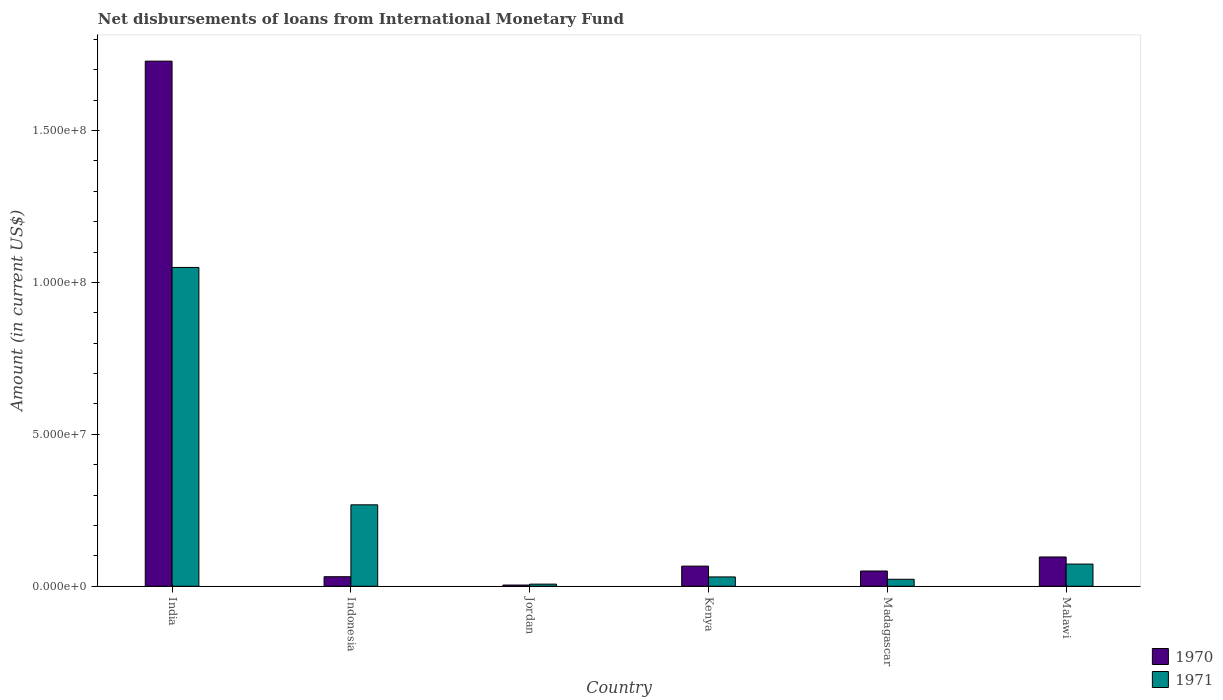How many groups of bars are there?
Give a very brief answer. 6. What is the label of the 2nd group of bars from the left?
Provide a short and direct response. Indonesia. What is the amount of loans disbursed in 1970 in Kenya?
Provide a succinct answer. 6.63e+06. Across all countries, what is the maximum amount of loans disbursed in 1971?
Your answer should be very brief. 1.05e+08. Across all countries, what is the minimum amount of loans disbursed in 1971?
Ensure brevity in your answer.  6.99e+05. In which country was the amount of loans disbursed in 1971 maximum?
Provide a short and direct response. India. In which country was the amount of loans disbursed in 1971 minimum?
Offer a very short reply. Jordan. What is the total amount of loans disbursed in 1970 in the graph?
Make the answer very short. 1.98e+08. What is the difference between the amount of loans disbursed in 1971 in Indonesia and that in Madagascar?
Your response must be concise. 2.45e+07. What is the difference between the amount of loans disbursed in 1970 in Indonesia and the amount of loans disbursed in 1971 in India?
Your response must be concise. -1.02e+08. What is the average amount of loans disbursed in 1971 per country?
Your answer should be compact. 2.42e+07. What is the difference between the amount of loans disbursed of/in 1970 and amount of loans disbursed of/in 1971 in India?
Give a very brief answer. 6.79e+07. In how many countries, is the amount of loans disbursed in 1971 greater than 100000000 US$?
Provide a short and direct response. 1. What is the ratio of the amount of loans disbursed in 1971 in India to that in Jordan?
Offer a terse response. 150.14. Is the difference between the amount of loans disbursed in 1970 in India and Jordan greater than the difference between the amount of loans disbursed in 1971 in India and Jordan?
Your answer should be very brief. Yes. What is the difference between the highest and the second highest amount of loans disbursed in 1971?
Ensure brevity in your answer.  9.76e+07. What is the difference between the highest and the lowest amount of loans disbursed in 1971?
Keep it short and to the point. 1.04e+08. Is the sum of the amount of loans disbursed in 1970 in Indonesia and Kenya greater than the maximum amount of loans disbursed in 1971 across all countries?
Make the answer very short. No. What does the 1st bar from the left in India represents?
Make the answer very short. 1970. What does the 1st bar from the right in Indonesia represents?
Your response must be concise. 1971. How many bars are there?
Provide a succinct answer. 12. How many countries are there in the graph?
Provide a short and direct response. 6. Are the values on the major ticks of Y-axis written in scientific E-notation?
Offer a terse response. Yes. Does the graph contain grids?
Give a very brief answer. No. How many legend labels are there?
Your answer should be very brief. 2. What is the title of the graph?
Your response must be concise. Net disbursements of loans from International Monetary Fund. Does "1966" appear as one of the legend labels in the graph?
Ensure brevity in your answer.  No. What is the label or title of the X-axis?
Ensure brevity in your answer.  Country. What is the Amount (in current US$) in 1970 in India?
Offer a terse response. 1.73e+08. What is the Amount (in current US$) in 1971 in India?
Your answer should be very brief. 1.05e+08. What is the Amount (in current US$) of 1970 in Indonesia?
Offer a very short reply. 3.14e+06. What is the Amount (in current US$) of 1971 in Indonesia?
Provide a succinct answer. 2.68e+07. What is the Amount (in current US$) in 1970 in Jordan?
Ensure brevity in your answer.  3.99e+05. What is the Amount (in current US$) of 1971 in Jordan?
Your answer should be very brief. 6.99e+05. What is the Amount (in current US$) of 1970 in Kenya?
Offer a very short reply. 6.63e+06. What is the Amount (in current US$) of 1971 in Kenya?
Keep it short and to the point. 3.07e+06. What is the Amount (in current US$) of 1970 in Madagascar?
Keep it short and to the point. 5.02e+06. What is the Amount (in current US$) of 1971 in Madagascar?
Give a very brief answer. 2.30e+06. What is the Amount (in current US$) of 1970 in Malawi?
Your response must be concise. 9.64e+06. What is the Amount (in current US$) in 1971 in Malawi?
Give a very brief answer. 7.30e+06. Across all countries, what is the maximum Amount (in current US$) in 1970?
Offer a terse response. 1.73e+08. Across all countries, what is the maximum Amount (in current US$) in 1971?
Make the answer very short. 1.05e+08. Across all countries, what is the minimum Amount (in current US$) of 1970?
Your answer should be compact. 3.99e+05. Across all countries, what is the minimum Amount (in current US$) in 1971?
Your answer should be very brief. 6.99e+05. What is the total Amount (in current US$) of 1970 in the graph?
Your answer should be compact. 1.98e+08. What is the total Amount (in current US$) of 1971 in the graph?
Keep it short and to the point. 1.45e+08. What is the difference between the Amount (in current US$) of 1970 in India and that in Indonesia?
Your answer should be compact. 1.70e+08. What is the difference between the Amount (in current US$) of 1971 in India and that in Indonesia?
Ensure brevity in your answer.  7.81e+07. What is the difference between the Amount (in current US$) of 1970 in India and that in Jordan?
Make the answer very short. 1.72e+08. What is the difference between the Amount (in current US$) in 1971 in India and that in Jordan?
Offer a terse response. 1.04e+08. What is the difference between the Amount (in current US$) of 1970 in India and that in Kenya?
Make the answer very short. 1.66e+08. What is the difference between the Amount (in current US$) in 1971 in India and that in Kenya?
Your response must be concise. 1.02e+08. What is the difference between the Amount (in current US$) of 1970 in India and that in Madagascar?
Give a very brief answer. 1.68e+08. What is the difference between the Amount (in current US$) in 1971 in India and that in Madagascar?
Offer a very short reply. 1.03e+08. What is the difference between the Amount (in current US$) in 1970 in India and that in Malawi?
Ensure brevity in your answer.  1.63e+08. What is the difference between the Amount (in current US$) in 1971 in India and that in Malawi?
Your answer should be compact. 9.76e+07. What is the difference between the Amount (in current US$) of 1970 in Indonesia and that in Jordan?
Make the answer very short. 2.74e+06. What is the difference between the Amount (in current US$) in 1971 in Indonesia and that in Jordan?
Offer a very short reply. 2.61e+07. What is the difference between the Amount (in current US$) of 1970 in Indonesia and that in Kenya?
Your response must be concise. -3.49e+06. What is the difference between the Amount (in current US$) in 1971 in Indonesia and that in Kenya?
Ensure brevity in your answer.  2.37e+07. What is the difference between the Amount (in current US$) in 1970 in Indonesia and that in Madagascar?
Offer a very short reply. -1.88e+06. What is the difference between the Amount (in current US$) of 1971 in Indonesia and that in Madagascar?
Your answer should be compact. 2.45e+07. What is the difference between the Amount (in current US$) of 1970 in Indonesia and that in Malawi?
Ensure brevity in your answer.  -6.50e+06. What is the difference between the Amount (in current US$) in 1971 in Indonesia and that in Malawi?
Make the answer very short. 1.95e+07. What is the difference between the Amount (in current US$) in 1970 in Jordan and that in Kenya?
Make the answer very short. -6.23e+06. What is the difference between the Amount (in current US$) in 1971 in Jordan and that in Kenya?
Offer a very short reply. -2.37e+06. What is the difference between the Amount (in current US$) in 1970 in Jordan and that in Madagascar?
Offer a very short reply. -4.62e+06. What is the difference between the Amount (in current US$) in 1971 in Jordan and that in Madagascar?
Your response must be concise. -1.60e+06. What is the difference between the Amount (in current US$) in 1970 in Jordan and that in Malawi?
Ensure brevity in your answer.  -9.24e+06. What is the difference between the Amount (in current US$) in 1971 in Jordan and that in Malawi?
Your response must be concise. -6.60e+06. What is the difference between the Amount (in current US$) of 1970 in Kenya and that in Madagascar?
Offer a very short reply. 1.61e+06. What is the difference between the Amount (in current US$) in 1971 in Kenya and that in Madagascar?
Provide a short and direct response. 7.69e+05. What is the difference between the Amount (in current US$) of 1970 in Kenya and that in Malawi?
Your answer should be compact. -3.01e+06. What is the difference between the Amount (in current US$) of 1971 in Kenya and that in Malawi?
Give a very brief answer. -4.24e+06. What is the difference between the Amount (in current US$) of 1970 in Madagascar and that in Malawi?
Provide a short and direct response. -4.62e+06. What is the difference between the Amount (in current US$) in 1971 in Madagascar and that in Malawi?
Make the answer very short. -5.00e+06. What is the difference between the Amount (in current US$) of 1970 in India and the Amount (in current US$) of 1971 in Indonesia?
Your answer should be compact. 1.46e+08. What is the difference between the Amount (in current US$) in 1970 in India and the Amount (in current US$) in 1971 in Jordan?
Give a very brief answer. 1.72e+08. What is the difference between the Amount (in current US$) of 1970 in India and the Amount (in current US$) of 1971 in Kenya?
Provide a short and direct response. 1.70e+08. What is the difference between the Amount (in current US$) of 1970 in India and the Amount (in current US$) of 1971 in Madagascar?
Provide a short and direct response. 1.71e+08. What is the difference between the Amount (in current US$) of 1970 in India and the Amount (in current US$) of 1971 in Malawi?
Give a very brief answer. 1.66e+08. What is the difference between the Amount (in current US$) of 1970 in Indonesia and the Amount (in current US$) of 1971 in Jordan?
Your response must be concise. 2.44e+06. What is the difference between the Amount (in current US$) in 1970 in Indonesia and the Amount (in current US$) in 1971 in Kenya?
Provide a short and direct response. 7.30e+04. What is the difference between the Amount (in current US$) of 1970 in Indonesia and the Amount (in current US$) of 1971 in Madagascar?
Keep it short and to the point. 8.42e+05. What is the difference between the Amount (in current US$) of 1970 in Indonesia and the Amount (in current US$) of 1971 in Malawi?
Make the answer very short. -4.16e+06. What is the difference between the Amount (in current US$) of 1970 in Jordan and the Amount (in current US$) of 1971 in Kenya?
Offer a very short reply. -2.67e+06. What is the difference between the Amount (in current US$) in 1970 in Jordan and the Amount (in current US$) in 1971 in Madagascar?
Your response must be concise. -1.90e+06. What is the difference between the Amount (in current US$) of 1970 in Jordan and the Amount (in current US$) of 1971 in Malawi?
Your response must be concise. -6.90e+06. What is the difference between the Amount (in current US$) of 1970 in Kenya and the Amount (in current US$) of 1971 in Madagascar?
Keep it short and to the point. 4.33e+06. What is the difference between the Amount (in current US$) of 1970 in Kenya and the Amount (in current US$) of 1971 in Malawi?
Ensure brevity in your answer.  -6.74e+05. What is the difference between the Amount (in current US$) of 1970 in Madagascar and the Amount (in current US$) of 1971 in Malawi?
Give a very brief answer. -2.28e+06. What is the average Amount (in current US$) of 1970 per country?
Your answer should be very brief. 3.29e+07. What is the average Amount (in current US$) in 1971 per country?
Your response must be concise. 2.42e+07. What is the difference between the Amount (in current US$) of 1970 and Amount (in current US$) of 1971 in India?
Provide a succinct answer. 6.79e+07. What is the difference between the Amount (in current US$) of 1970 and Amount (in current US$) of 1971 in Indonesia?
Your answer should be compact. -2.37e+07. What is the difference between the Amount (in current US$) of 1970 and Amount (in current US$) of 1971 in Kenya?
Make the answer very short. 3.56e+06. What is the difference between the Amount (in current US$) in 1970 and Amount (in current US$) in 1971 in Madagascar?
Keep it short and to the point. 2.72e+06. What is the difference between the Amount (in current US$) of 1970 and Amount (in current US$) of 1971 in Malawi?
Your answer should be very brief. 2.33e+06. What is the ratio of the Amount (in current US$) in 1970 in India to that in Indonesia?
Offer a very short reply. 55.07. What is the ratio of the Amount (in current US$) of 1971 in India to that in Indonesia?
Give a very brief answer. 3.91. What is the ratio of the Amount (in current US$) in 1970 in India to that in Jordan?
Your answer should be very brief. 433.25. What is the ratio of the Amount (in current US$) in 1971 in India to that in Jordan?
Ensure brevity in your answer.  150.14. What is the ratio of the Amount (in current US$) in 1970 in India to that in Kenya?
Give a very brief answer. 26.08. What is the ratio of the Amount (in current US$) of 1971 in India to that in Kenya?
Offer a terse response. 34.23. What is the ratio of the Amount (in current US$) in 1970 in India to that in Madagascar?
Keep it short and to the point. 34.45. What is the ratio of the Amount (in current US$) in 1971 in India to that in Madagascar?
Your response must be concise. 45.69. What is the ratio of the Amount (in current US$) in 1970 in India to that in Malawi?
Offer a terse response. 17.94. What is the ratio of the Amount (in current US$) in 1971 in India to that in Malawi?
Provide a short and direct response. 14.37. What is the ratio of the Amount (in current US$) of 1970 in Indonesia to that in Jordan?
Provide a succinct answer. 7.87. What is the ratio of the Amount (in current US$) of 1971 in Indonesia to that in Jordan?
Provide a succinct answer. 38.35. What is the ratio of the Amount (in current US$) in 1970 in Indonesia to that in Kenya?
Keep it short and to the point. 0.47. What is the ratio of the Amount (in current US$) of 1971 in Indonesia to that in Kenya?
Provide a short and direct response. 8.74. What is the ratio of the Amount (in current US$) in 1970 in Indonesia to that in Madagascar?
Keep it short and to the point. 0.63. What is the ratio of the Amount (in current US$) of 1971 in Indonesia to that in Madagascar?
Offer a very short reply. 11.67. What is the ratio of the Amount (in current US$) of 1970 in Indonesia to that in Malawi?
Make the answer very short. 0.33. What is the ratio of the Amount (in current US$) in 1971 in Indonesia to that in Malawi?
Give a very brief answer. 3.67. What is the ratio of the Amount (in current US$) of 1970 in Jordan to that in Kenya?
Your response must be concise. 0.06. What is the ratio of the Amount (in current US$) of 1971 in Jordan to that in Kenya?
Offer a terse response. 0.23. What is the ratio of the Amount (in current US$) in 1970 in Jordan to that in Madagascar?
Offer a terse response. 0.08. What is the ratio of the Amount (in current US$) in 1971 in Jordan to that in Madagascar?
Provide a succinct answer. 0.3. What is the ratio of the Amount (in current US$) of 1970 in Jordan to that in Malawi?
Provide a succinct answer. 0.04. What is the ratio of the Amount (in current US$) in 1971 in Jordan to that in Malawi?
Offer a very short reply. 0.1. What is the ratio of the Amount (in current US$) in 1970 in Kenya to that in Madagascar?
Make the answer very short. 1.32. What is the ratio of the Amount (in current US$) of 1971 in Kenya to that in Madagascar?
Offer a terse response. 1.33. What is the ratio of the Amount (in current US$) of 1970 in Kenya to that in Malawi?
Offer a very short reply. 0.69. What is the ratio of the Amount (in current US$) in 1971 in Kenya to that in Malawi?
Provide a short and direct response. 0.42. What is the ratio of the Amount (in current US$) of 1970 in Madagascar to that in Malawi?
Offer a very short reply. 0.52. What is the ratio of the Amount (in current US$) in 1971 in Madagascar to that in Malawi?
Offer a very short reply. 0.31. What is the difference between the highest and the second highest Amount (in current US$) of 1970?
Make the answer very short. 1.63e+08. What is the difference between the highest and the second highest Amount (in current US$) in 1971?
Ensure brevity in your answer.  7.81e+07. What is the difference between the highest and the lowest Amount (in current US$) in 1970?
Offer a very short reply. 1.72e+08. What is the difference between the highest and the lowest Amount (in current US$) in 1971?
Your answer should be very brief. 1.04e+08. 